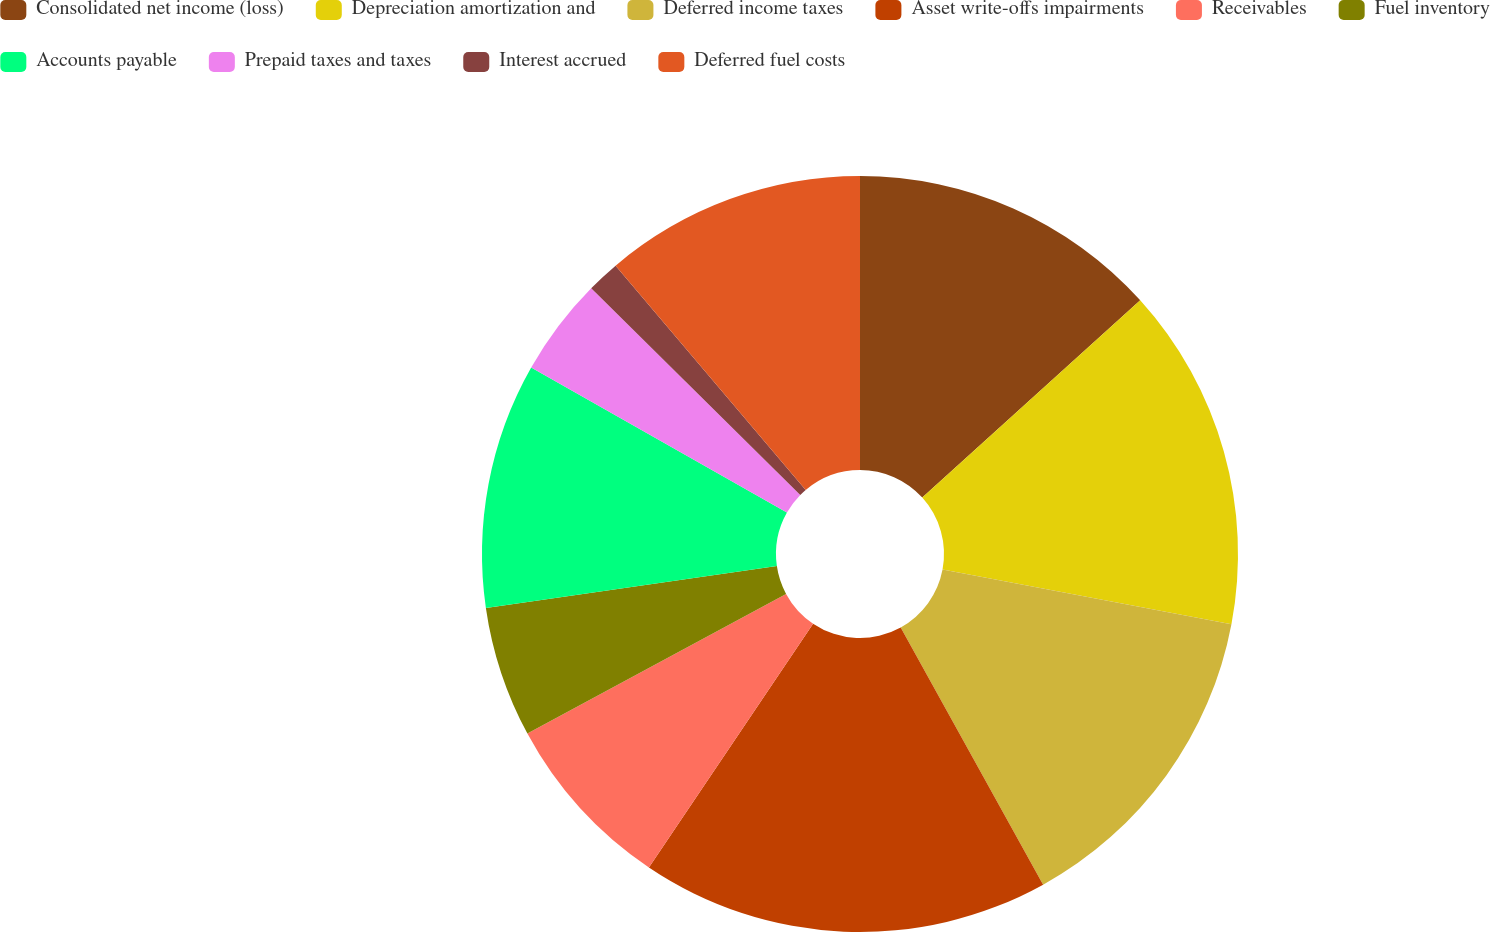<chart> <loc_0><loc_0><loc_500><loc_500><pie_chart><fcel>Consolidated net income (loss)<fcel>Depreciation amortization and<fcel>Deferred income taxes<fcel>Asset write-offs impairments<fcel>Receivables<fcel>Fuel inventory<fcel>Accounts payable<fcel>Prepaid taxes and taxes<fcel>Interest accrued<fcel>Deferred fuel costs<nl><fcel>13.29%<fcel>14.68%<fcel>13.98%<fcel>17.48%<fcel>7.69%<fcel>5.6%<fcel>10.49%<fcel>4.2%<fcel>1.4%<fcel>11.19%<nl></chart> 